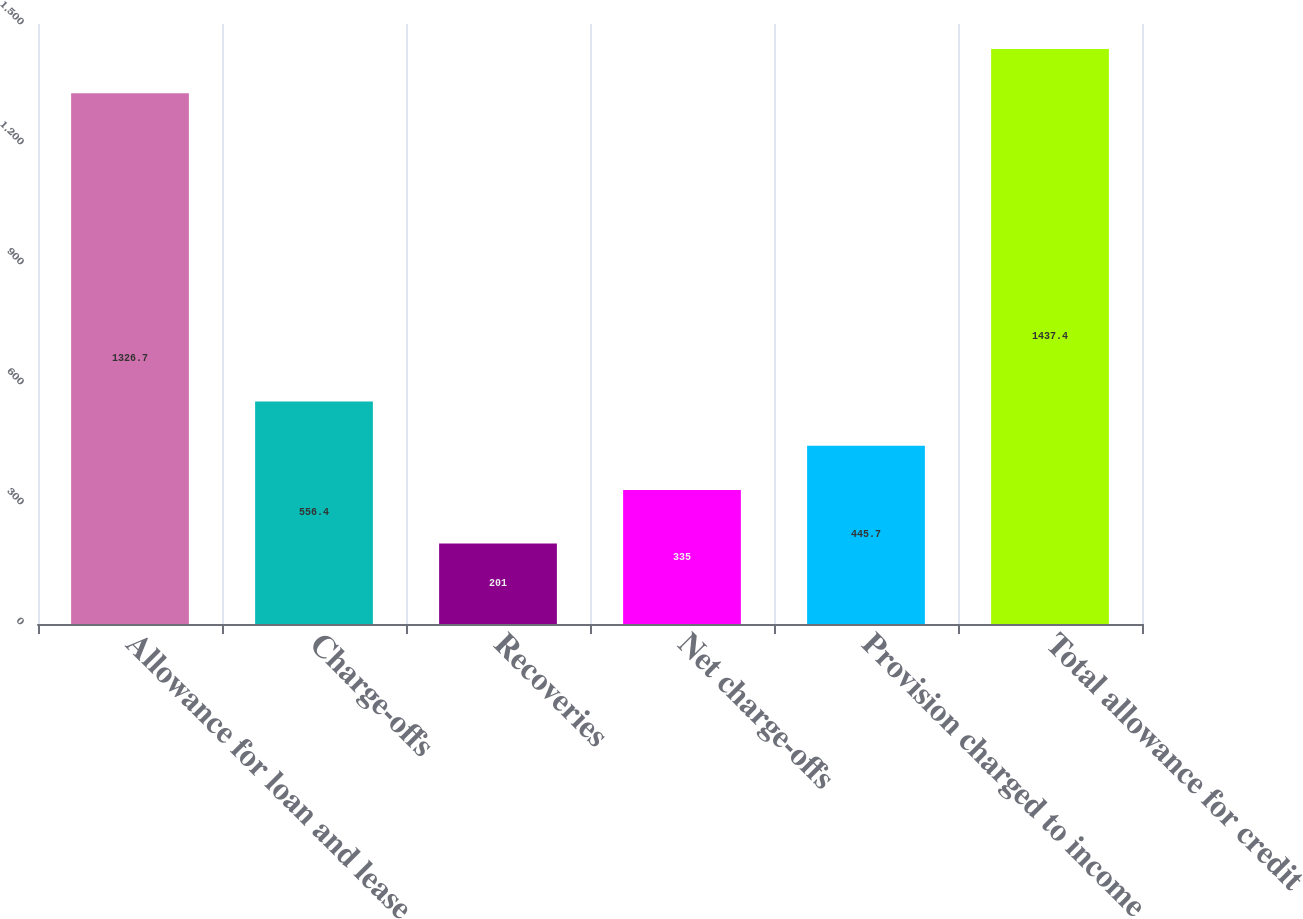<chart> <loc_0><loc_0><loc_500><loc_500><bar_chart><fcel>Allowance for loan and lease<fcel>Charge-offs<fcel>Recoveries<fcel>Net charge-offs<fcel>Provision charged to income<fcel>Total allowance for credit<nl><fcel>1326.7<fcel>556.4<fcel>201<fcel>335<fcel>445.7<fcel>1437.4<nl></chart> 